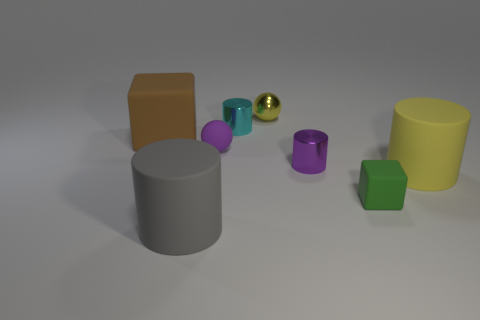Subtract 1 cylinders. How many cylinders are left? 3 Add 2 small gray metallic cylinders. How many objects exist? 10 Subtract all spheres. How many objects are left? 6 Subtract all tiny purple spheres. Subtract all big brown matte cubes. How many objects are left? 6 Add 5 big matte objects. How many big matte objects are left? 8 Add 2 big yellow shiny objects. How many big yellow shiny objects exist? 2 Subtract 0 gray blocks. How many objects are left? 8 